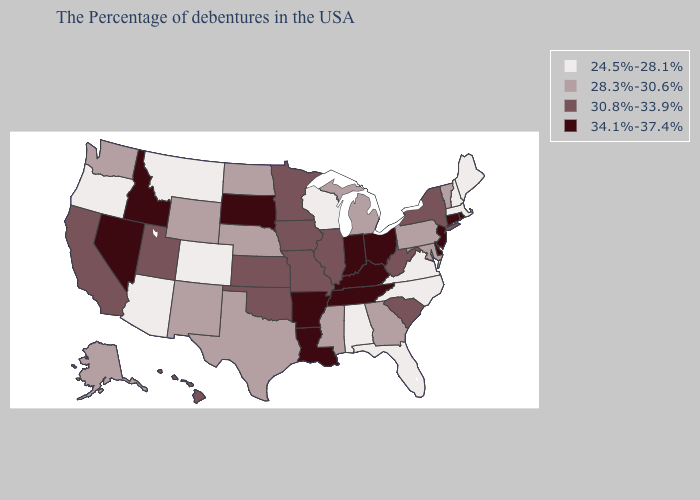Which states have the lowest value in the Northeast?
Give a very brief answer. Maine, Massachusetts, New Hampshire. Name the states that have a value in the range 28.3%-30.6%?
Be succinct. Vermont, Maryland, Pennsylvania, Georgia, Michigan, Mississippi, Nebraska, Texas, North Dakota, Wyoming, New Mexico, Washington, Alaska. What is the value of Arizona?
Quick response, please. 24.5%-28.1%. What is the highest value in the USA?
Quick response, please. 34.1%-37.4%. Name the states that have a value in the range 34.1%-37.4%?
Write a very short answer. Rhode Island, Connecticut, New Jersey, Delaware, Ohio, Kentucky, Indiana, Tennessee, Louisiana, Arkansas, South Dakota, Idaho, Nevada. Name the states that have a value in the range 28.3%-30.6%?
Be succinct. Vermont, Maryland, Pennsylvania, Georgia, Michigan, Mississippi, Nebraska, Texas, North Dakota, Wyoming, New Mexico, Washington, Alaska. Does the first symbol in the legend represent the smallest category?
Give a very brief answer. Yes. Which states have the highest value in the USA?
Be succinct. Rhode Island, Connecticut, New Jersey, Delaware, Ohio, Kentucky, Indiana, Tennessee, Louisiana, Arkansas, South Dakota, Idaho, Nevada. Name the states that have a value in the range 24.5%-28.1%?
Quick response, please. Maine, Massachusetts, New Hampshire, Virginia, North Carolina, Florida, Alabama, Wisconsin, Colorado, Montana, Arizona, Oregon. What is the value of New Hampshire?
Answer briefly. 24.5%-28.1%. How many symbols are there in the legend?
Write a very short answer. 4. What is the value of Florida?
Quick response, please. 24.5%-28.1%. What is the value of Colorado?
Be succinct. 24.5%-28.1%. Does Ohio have the highest value in the MidWest?
Be succinct. Yes. What is the highest value in the USA?
Be succinct. 34.1%-37.4%. 